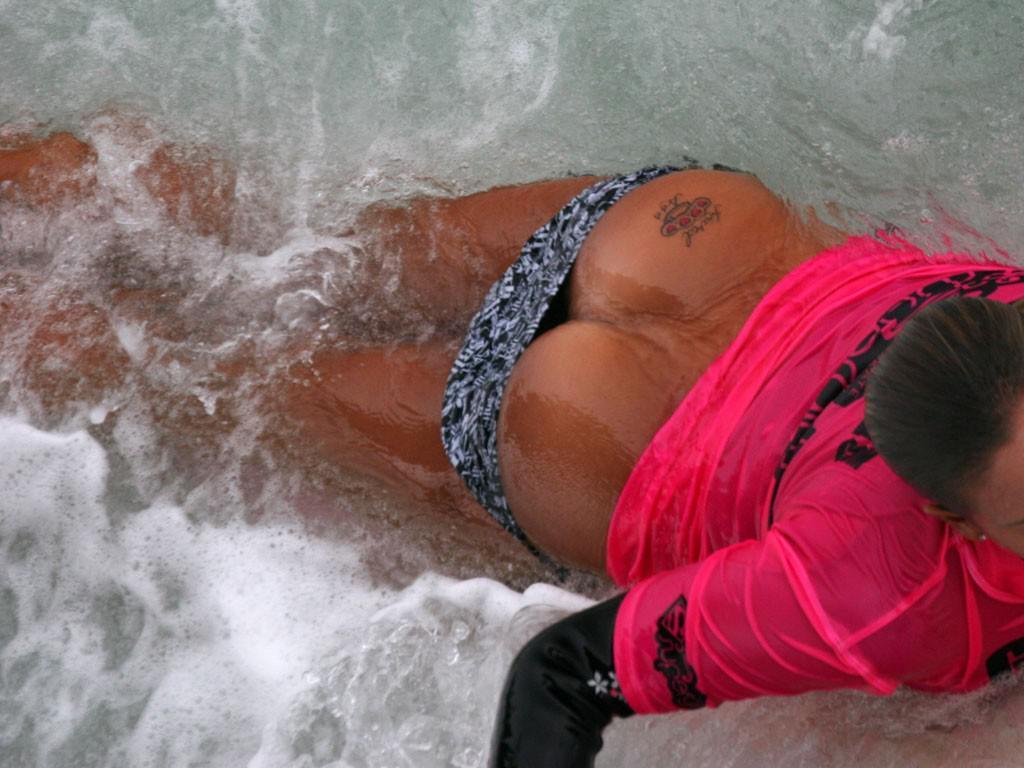Describe this image in one or two sentences. In this image we can see a person swimming in the water. 